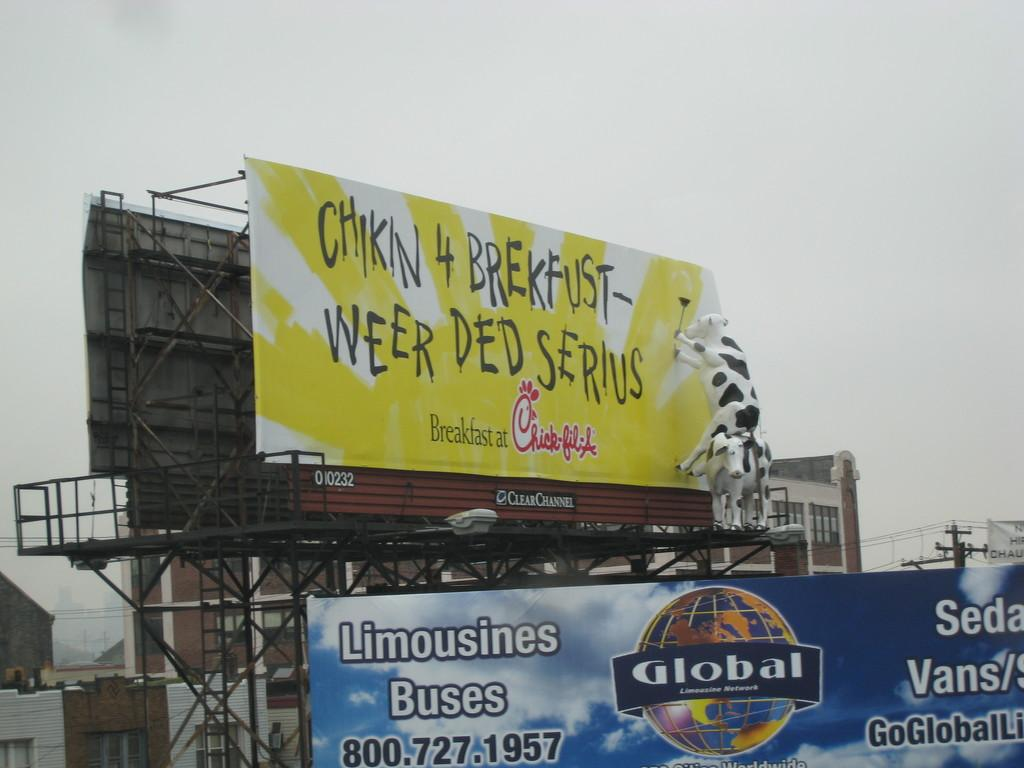<image>
Describe the image concisely. billboards outside for Chick-fil-A and Global Limousine Network 